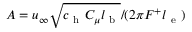<formula> <loc_0><loc_0><loc_500><loc_500>A = u _ { \infty } \sqrt { c _ { h } C _ { \mu } l _ { b } } / ( 2 \pi F ^ { + } l _ { e } )</formula> 